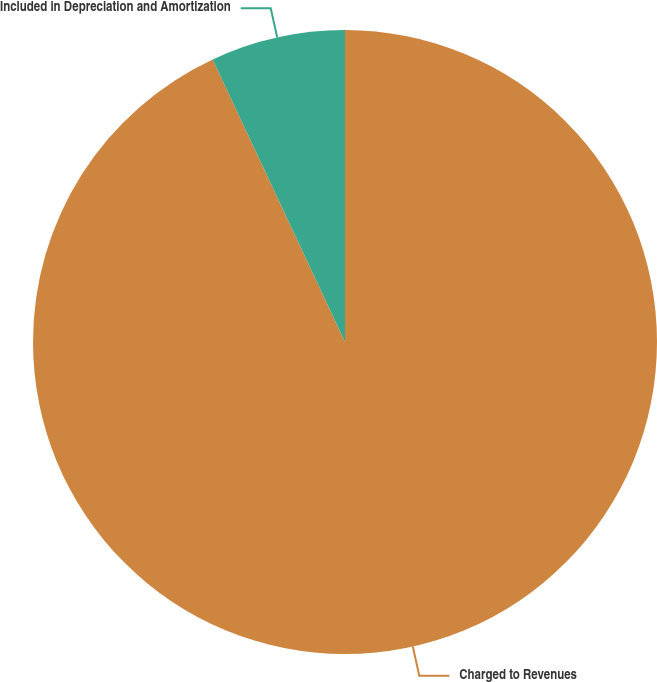Convert chart to OTSL. <chart><loc_0><loc_0><loc_500><loc_500><pie_chart><fcel>Charged to Revenues<fcel>Included in Depreciation and Amortization<nl><fcel>93.03%<fcel>6.97%<nl></chart> 